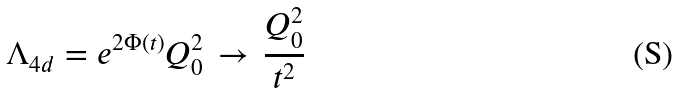Convert formula to latex. <formula><loc_0><loc_0><loc_500><loc_500>\Lambda _ { 4 d } = e ^ { 2 \Phi ( t ) } Q _ { 0 } ^ { 2 } \, \to \, \frac { Q _ { 0 } ^ { 2 } } { t ^ { 2 } }</formula> 